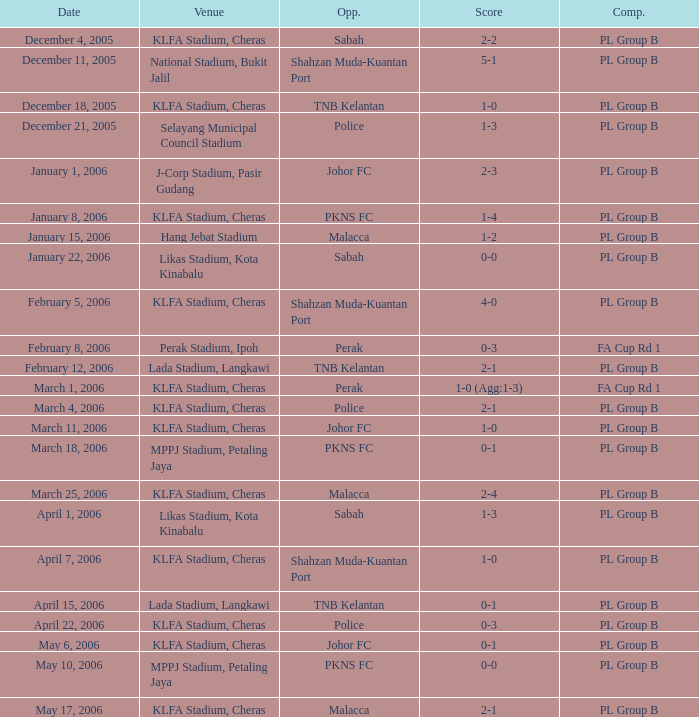Which Competition has a Score of 0-1, and Opponents of pkns fc? PL Group B. 